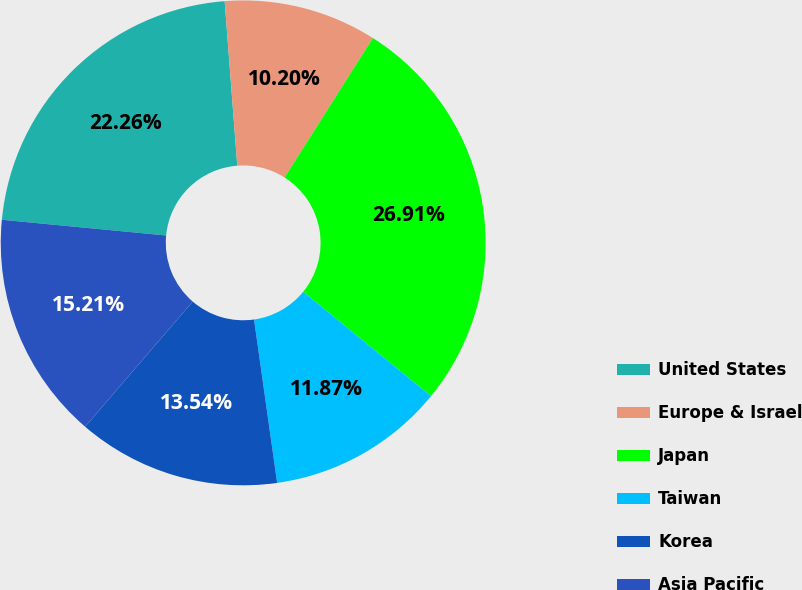Convert chart to OTSL. <chart><loc_0><loc_0><loc_500><loc_500><pie_chart><fcel>United States<fcel>Europe & Israel<fcel>Japan<fcel>Taiwan<fcel>Korea<fcel>Asia Pacific<nl><fcel>22.26%<fcel>10.2%<fcel>26.9%<fcel>11.87%<fcel>13.54%<fcel>15.21%<nl></chart> 